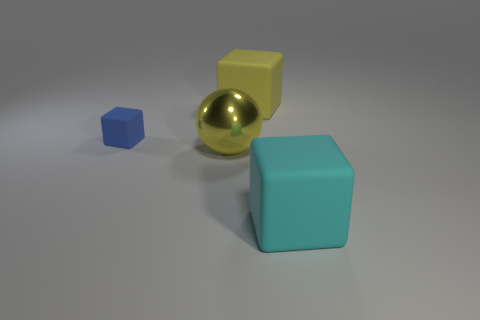Can you describe the colors and shapes visible in this image? Certainly! In the image, we have four geometric shapes: a small blue cube on the left, followed by a small shiny gold sphere, a medium-sized yellow cube, and a large teal cube on the far right. Each object stands out with its distinct color and shape against a neutral gray background. 